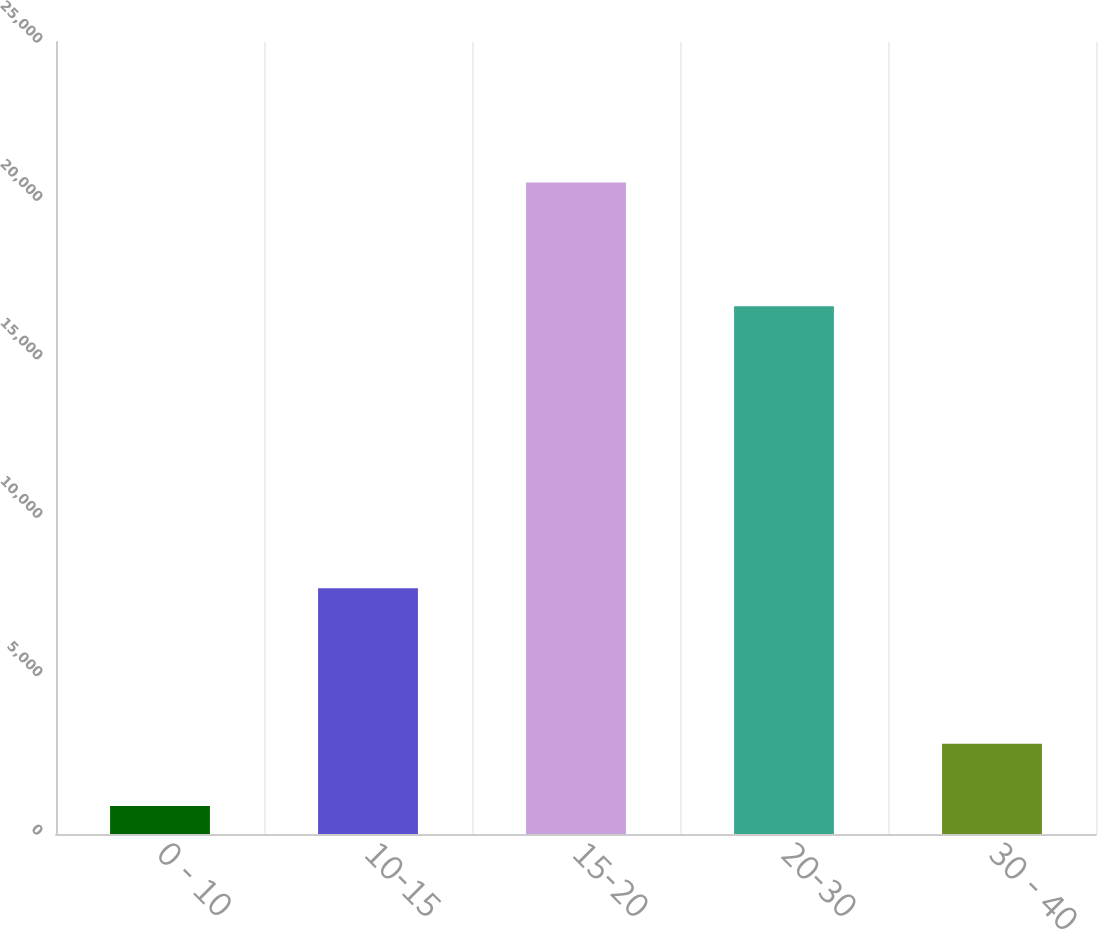<chart> <loc_0><loc_0><loc_500><loc_500><bar_chart><fcel>0 - 10<fcel>10-15<fcel>15-20<fcel>20-30<fcel>30 - 40<nl><fcel>882<fcel>7757<fcel>20568<fcel>16656<fcel>2850.6<nl></chart> 